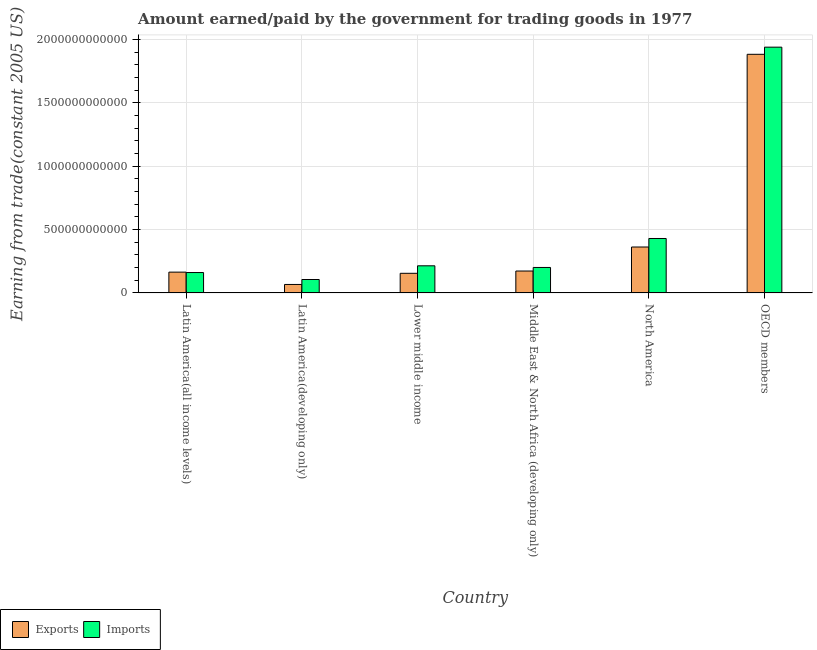How many bars are there on the 5th tick from the right?
Provide a succinct answer. 2. What is the label of the 4th group of bars from the left?
Your answer should be compact. Middle East & North Africa (developing only). In how many cases, is the number of bars for a given country not equal to the number of legend labels?
Provide a succinct answer. 0. What is the amount earned from exports in Middle East & North Africa (developing only)?
Make the answer very short. 1.73e+11. Across all countries, what is the maximum amount earned from exports?
Your answer should be compact. 1.88e+12. Across all countries, what is the minimum amount earned from exports?
Your response must be concise. 6.69e+1. In which country was the amount earned from exports minimum?
Make the answer very short. Latin America(developing only). What is the total amount paid for imports in the graph?
Give a very brief answer. 3.05e+12. What is the difference between the amount paid for imports in Latin America(all income levels) and that in OECD members?
Provide a short and direct response. -1.78e+12. What is the difference between the amount paid for imports in Middle East & North Africa (developing only) and the amount earned from exports in North America?
Give a very brief answer. -1.61e+11. What is the average amount earned from exports per country?
Provide a short and direct response. 4.67e+11. What is the difference between the amount paid for imports and amount earned from exports in Latin America(developing only)?
Your answer should be compact. 3.91e+1. What is the ratio of the amount paid for imports in Latin America(developing only) to that in OECD members?
Your response must be concise. 0.05. Is the amount earned from exports in Latin America(developing only) less than that in North America?
Your answer should be compact. Yes. What is the difference between the highest and the second highest amount earned from exports?
Your answer should be compact. 1.52e+12. What is the difference between the highest and the lowest amount paid for imports?
Offer a very short reply. 1.83e+12. In how many countries, is the amount earned from exports greater than the average amount earned from exports taken over all countries?
Your answer should be very brief. 1. Is the sum of the amount paid for imports in Latin America(developing only) and Middle East & North Africa (developing only) greater than the maximum amount earned from exports across all countries?
Keep it short and to the point. No. What does the 1st bar from the left in Lower middle income represents?
Offer a terse response. Exports. What does the 1st bar from the right in Latin America(all income levels) represents?
Your answer should be very brief. Imports. How many bars are there?
Your answer should be compact. 12. What is the difference between two consecutive major ticks on the Y-axis?
Your response must be concise. 5.00e+11. Are the values on the major ticks of Y-axis written in scientific E-notation?
Offer a terse response. No. Does the graph contain grids?
Keep it short and to the point. Yes. How many legend labels are there?
Make the answer very short. 2. How are the legend labels stacked?
Ensure brevity in your answer.  Horizontal. What is the title of the graph?
Ensure brevity in your answer.  Amount earned/paid by the government for trading goods in 1977. Does "Overweight" appear as one of the legend labels in the graph?
Keep it short and to the point. No. What is the label or title of the X-axis?
Your answer should be very brief. Country. What is the label or title of the Y-axis?
Your response must be concise. Earning from trade(constant 2005 US). What is the Earning from trade(constant 2005 US) of Exports in Latin America(all income levels)?
Offer a terse response. 1.64e+11. What is the Earning from trade(constant 2005 US) of Imports in Latin America(all income levels)?
Keep it short and to the point. 1.61e+11. What is the Earning from trade(constant 2005 US) of Exports in Latin America(developing only)?
Provide a succinct answer. 6.69e+1. What is the Earning from trade(constant 2005 US) in Imports in Latin America(developing only)?
Make the answer very short. 1.06e+11. What is the Earning from trade(constant 2005 US) of Exports in Lower middle income?
Ensure brevity in your answer.  1.55e+11. What is the Earning from trade(constant 2005 US) in Imports in Lower middle income?
Your response must be concise. 2.14e+11. What is the Earning from trade(constant 2005 US) of Exports in Middle East & North Africa (developing only)?
Offer a terse response. 1.73e+11. What is the Earning from trade(constant 2005 US) in Imports in Middle East & North Africa (developing only)?
Ensure brevity in your answer.  2.01e+11. What is the Earning from trade(constant 2005 US) in Exports in North America?
Give a very brief answer. 3.62e+11. What is the Earning from trade(constant 2005 US) in Imports in North America?
Offer a terse response. 4.29e+11. What is the Earning from trade(constant 2005 US) of Exports in OECD members?
Your answer should be compact. 1.88e+12. What is the Earning from trade(constant 2005 US) in Imports in OECD members?
Make the answer very short. 1.94e+12. Across all countries, what is the maximum Earning from trade(constant 2005 US) of Exports?
Your answer should be compact. 1.88e+12. Across all countries, what is the maximum Earning from trade(constant 2005 US) of Imports?
Give a very brief answer. 1.94e+12. Across all countries, what is the minimum Earning from trade(constant 2005 US) of Exports?
Provide a short and direct response. 6.69e+1. Across all countries, what is the minimum Earning from trade(constant 2005 US) of Imports?
Offer a very short reply. 1.06e+11. What is the total Earning from trade(constant 2005 US) in Exports in the graph?
Keep it short and to the point. 2.80e+12. What is the total Earning from trade(constant 2005 US) in Imports in the graph?
Give a very brief answer. 3.05e+12. What is the difference between the Earning from trade(constant 2005 US) in Exports in Latin America(all income levels) and that in Latin America(developing only)?
Provide a succinct answer. 9.72e+1. What is the difference between the Earning from trade(constant 2005 US) in Imports in Latin America(all income levels) and that in Latin America(developing only)?
Ensure brevity in your answer.  5.50e+1. What is the difference between the Earning from trade(constant 2005 US) of Exports in Latin America(all income levels) and that in Lower middle income?
Your answer should be compact. 9.28e+09. What is the difference between the Earning from trade(constant 2005 US) in Imports in Latin America(all income levels) and that in Lower middle income?
Provide a succinct answer. -5.31e+1. What is the difference between the Earning from trade(constant 2005 US) in Exports in Latin America(all income levels) and that in Middle East & North Africa (developing only)?
Provide a short and direct response. -8.78e+09. What is the difference between the Earning from trade(constant 2005 US) of Imports in Latin America(all income levels) and that in Middle East & North Africa (developing only)?
Your answer should be compact. -4.00e+1. What is the difference between the Earning from trade(constant 2005 US) of Exports in Latin America(all income levels) and that in North America?
Give a very brief answer. -1.98e+11. What is the difference between the Earning from trade(constant 2005 US) of Imports in Latin America(all income levels) and that in North America?
Offer a very short reply. -2.69e+11. What is the difference between the Earning from trade(constant 2005 US) in Exports in Latin America(all income levels) and that in OECD members?
Offer a very short reply. -1.72e+12. What is the difference between the Earning from trade(constant 2005 US) in Imports in Latin America(all income levels) and that in OECD members?
Offer a very short reply. -1.78e+12. What is the difference between the Earning from trade(constant 2005 US) of Exports in Latin America(developing only) and that in Lower middle income?
Provide a succinct answer. -8.79e+1. What is the difference between the Earning from trade(constant 2005 US) of Imports in Latin America(developing only) and that in Lower middle income?
Offer a very short reply. -1.08e+11. What is the difference between the Earning from trade(constant 2005 US) in Exports in Latin America(developing only) and that in Middle East & North Africa (developing only)?
Your answer should be very brief. -1.06e+11. What is the difference between the Earning from trade(constant 2005 US) in Imports in Latin America(developing only) and that in Middle East & North Africa (developing only)?
Provide a succinct answer. -9.50e+1. What is the difference between the Earning from trade(constant 2005 US) of Exports in Latin America(developing only) and that in North America?
Your answer should be compact. -2.95e+11. What is the difference between the Earning from trade(constant 2005 US) of Imports in Latin America(developing only) and that in North America?
Offer a very short reply. -3.24e+11. What is the difference between the Earning from trade(constant 2005 US) of Exports in Latin America(developing only) and that in OECD members?
Offer a very short reply. -1.82e+12. What is the difference between the Earning from trade(constant 2005 US) in Imports in Latin America(developing only) and that in OECD members?
Your answer should be very brief. -1.83e+12. What is the difference between the Earning from trade(constant 2005 US) of Exports in Lower middle income and that in Middle East & North Africa (developing only)?
Provide a succinct answer. -1.81e+1. What is the difference between the Earning from trade(constant 2005 US) of Imports in Lower middle income and that in Middle East & North Africa (developing only)?
Make the answer very short. 1.31e+1. What is the difference between the Earning from trade(constant 2005 US) in Exports in Lower middle income and that in North America?
Provide a succinct answer. -2.07e+11. What is the difference between the Earning from trade(constant 2005 US) of Imports in Lower middle income and that in North America?
Your answer should be compact. -2.15e+11. What is the difference between the Earning from trade(constant 2005 US) in Exports in Lower middle income and that in OECD members?
Offer a terse response. -1.73e+12. What is the difference between the Earning from trade(constant 2005 US) of Imports in Lower middle income and that in OECD members?
Provide a short and direct response. -1.72e+12. What is the difference between the Earning from trade(constant 2005 US) in Exports in Middle East & North Africa (developing only) and that in North America?
Provide a succinct answer. -1.89e+11. What is the difference between the Earning from trade(constant 2005 US) in Imports in Middle East & North Africa (developing only) and that in North America?
Your answer should be very brief. -2.29e+11. What is the difference between the Earning from trade(constant 2005 US) in Exports in Middle East & North Africa (developing only) and that in OECD members?
Your answer should be compact. -1.71e+12. What is the difference between the Earning from trade(constant 2005 US) in Imports in Middle East & North Africa (developing only) and that in OECD members?
Keep it short and to the point. -1.74e+12. What is the difference between the Earning from trade(constant 2005 US) in Exports in North America and that in OECD members?
Keep it short and to the point. -1.52e+12. What is the difference between the Earning from trade(constant 2005 US) of Imports in North America and that in OECD members?
Make the answer very short. -1.51e+12. What is the difference between the Earning from trade(constant 2005 US) in Exports in Latin America(all income levels) and the Earning from trade(constant 2005 US) in Imports in Latin America(developing only)?
Your answer should be compact. 5.81e+1. What is the difference between the Earning from trade(constant 2005 US) in Exports in Latin America(all income levels) and the Earning from trade(constant 2005 US) in Imports in Lower middle income?
Your answer should be compact. -4.99e+1. What is the difference between the Earning from trade(constant 2005 US) of Exports in Latin America(all income levels) and the Earning from trade(constant 2005 US) of Imports in Middle East & North Africa (developing only)?
Ensure brevity in your answer.  -3.68e+1. What is the difference between the Earning from trade(constant 2005 US) in Exports in Latin America(all income levels) and the Earning from trade(constant 2005 US) in Imports in North America?
Ensure brevity in your answer.  -2.65e+11. What is the difference between the Earning from trade(constant 2005 US) of Exports in Latin America(all income levels) and the Earning from trade(constant 2005 US) of Imports in OECD members?
Provide a short and direct response. -1.77e+12. What is the difference between the Earning from trade(constant 2005 US) in Exports in Latin America(developing only) and the Earning from trade(constant 2005 US) in Imports in Lower middle income?
Your answer should be compact. -1.47e+11. What is the difference between the Earning from trade(constant 2005 US) of Exports in Latin America(developing only) and the Earning from trade(constant 2005 US) of Imports in Middle East & North Africa (developing only)?
Offer a terse response. -1.34e+11. What is the difference between the Earning from trade(constant 2005 US) of Exports in Latin America(developing only) and the Earning from trade(constant 2005 US) of Imports in North America?
Offer a terse response. -3.63e+11. What is the difference between the Earning from trade(constant 2005 US) in Exports in Latin America(developing only) and the Earning from trade(constant 2005 US) in Imports in OECD members?
Your answer should be compact. -1.87e+12. What is the difference between the Earning from trade(constant 2005 US) of Exports in Lower middle income and the Earning from trade(constant 2005 US) of Imports in Middle East & North Africa (developing only)?
Your answer should be compact. -4.61e+1. What is the difference between the Earning from trade(constant 2005 US) of Exports in Lower middle income and the Earning from trade(constant 2005 US) of Imports in North America?
Provide a short and direct response. -2.75e+11. What is the difference between the Earning from trade(constant 2005 US) in Exports in Lower middle income and the Earning from trade(constant 2005 US) in Imports in OECD members?
Provide a short and direct response. -1.78e+12. What is the difference between the Earning from trade(constant 2005 US) in Exports in Middle East & North Africa (developing only) and the Earning from trade(constant 2005 US) in Imports in North America?
Offer a terse response. -2.57e+11. What is the difference between the Earning from trade(constant 2005 US) in Exports in Middle East & North Africa (developing only) and the Earning from trade(constant 2005 US) in Imports in OECD members?
Your answer should be very brief. -1.77e+12. What is the difference between the Earning from trade(constant 2005 US) of Exports in North America and the Earning from trade(constant 2005 US) of Imports in OECD members?
Ensure brevity in your answer.  -1.58e+12. What is the average Earning from trade(constant 2005 US) of Exports per country?
Give a very brief answer. 4.67e+11. What is the average Earning from trade(constant 2005 US) in Imports per country?
Provide a succinct answer. 5.08e+11. What is the difference between the Earning from trade(constant 2005 US) of Exports and Earning from trade(constant 2005 US) of Imports in Latin America(all income levels)?
Your response must be concise. 3.17e+09. What is the difference between the Earning from trade(constant 2005 US) of Exports and Earning from trade(constant 2005 US) of Imports in Latin America(developing only)?
Your answer should be very brief. -3.91e+1. What is the difference between the Earning from trade(constant 2005 US) in Exports and Earning from trade(constant 2005 US) in Imports in Lower middle income?
Make the answer very short. -5.92e+1. What is the difference between the Earning from trade(constant 2005 US) of Exports and Earning from trade(constant 2005 US) of Imports in Middle East & North Africa (developing only)?
Your answer should be very brief. -2.81e+1. What is the difference between the Earning from trade(constant 2005 US) in Exports and Earning from trade(constant 2005 US) in Imports in North America?
Make the answer very short. -6.72e+1. What is the difference between the Earning from trade(constant 2005 US) of Exports and Earning from trade(constant 2005 US) of Imports in OECD members?
Your answer should be very brief. -5.63e+1. What is the ratio of the Earning from trade(constant 2005 US) of Exports in Latin America(all income levels) to that in Latin America(developing only)?
Offer a very short reply. 2.45. What is the ratio of the Earning from trade(constant 2005 US) of Imports in Latin America(all income levels) to that in Latin America(developing only)?
Your response must be concise. 1.52. What is the ratio of the Earning from trade(constant 2005 US) of Exports in Latin America(all income levels) to that in Lower middle income?
Your response must be concise. 1.06. What is the ratio of the Earning from trade(constant 2005 US) of Imports in Latin America(all income levels) to that in Lower middle income?
Your answer should be very brief. 0.75. What is the ratio of the Earning from trade(constant 2005 US) in Exports in Latin America(all income levels) to that in Middle East & North Africa (developing only)?
Offer a terse response. 0.95. What is the ratio of the Earning from trade(constant 2005 US) in Imports in Latin America(all income levels) to that in Middle East & North Africa (developing only)?
Provide a succinct answer. 0.8. What is the ratio of the Earning from trade(constant 2005 US) of Exports in Latin America(all income levels) to that in North America?
Keep it short and to the point. 0.45. What is the ratio of the Earning from trade(constant 2005 US) in Imports in Latin America(all income levels) to that in North America?
Your answer should be compact. 0.37. What is the ratio of the Earning from trade(constant 2005 US) in Exports in Latin America(all income levels) to that in OECD members?
Keep it short and to the point. 0.09. What is the ratio of the Earning from trade(constant 2005 US) in Imports in Latin America(all income levels) to that in OECD members?
Ensure brevity in your answer.  0.08. What is the ratio of the Earning from trade(constant 2005 US) in Exports in Latin America(developing only) to that in Lower middle income?
Offer a terse response. 0.43. What is the ratio of the Earning from trade(constant 2005 US) of Imports in Latin America(developing only) to that in Lower middle income?
Keep it short and to the point. 0.5. What is the ratio of the Earning from trade(constant 2005 US) in Exports in Latin America(developing only) to that in Middle East & North Africa (developing only)?
Ensure brevity in your answer.  0.39. What is the ratio of the Earning from trade(constant 2005 US) of Imports in Latin America(developing only) to that in Middle East & North Africa (developing only)?
Offer a terse response. 0.53. What is the ratio of the Earning from trade(constant 2005 US) of Exports in Latin America(developing only) to that in North America?
Your answer should be very brief. 0.18. What is the ratio of the Earning from trade(constant 2005 US) of Imports in Latin America(developing only) to that in North America?
Offer a terse response. 0.25. What is the ratio of the Earning from trade(constant 2005 US) of Exports in Latin America(developing only) to that in OECD members?
Your answer should be very brief. 0.04. What is the ratio of the Earning from trade(constant 2005 US) in Imports in Latin America(developing only) to that in OECD members?
Make the answer very short. 0.05. What is the ratio of the Earning from trade(constant 2005 US) of Exports in Lower middle income to that in Middle East & North Africa (developing only)?
Ensure brevity in your answer.  0.9. What is the ratio of the Earning from trade(constant 2005 US) in Imports in Lower middle income to that in Middle East & North Africa (developing only)?
Provide a succinct answer. 1.07. What is the ratio of the Earning from trade(constant 2005 US) of Exports in Lower middle income to that in North America?
Keep it short and to the point. 0.43. What is the ratio of the Earning from trade(constant 2005 US) of Imports in Lower middle income to that in North America?
Your answer should be compact. 0.5. What is the ratio of the Earning from trade(constant 2005 US) in Exports in Lower middle income to that in OECD members?
Keep it short and to the point. 0.08. What is the ratio of the Earning from trade(constant 2005 US) in Imports in Lower middle income to that in OECD members?
Offer a terse response. 0.11. What is the ratio of the Earning from trade(constant 2005 US) in Exports in Middle East & North Africa (developing only) to that in North America?
Ensure brevity in your answer.  0.48. What is the ratio of the Earning from trade(constant 2005 US) in Imports in Middle East & North Africa (developing only) to that in North America?
Make the answer very short. 0.47. What is the ratio of the Earning from trade(constant 2005 US) in Exports in Middle East & North Africa (developing only) to that in OECD members?
Provide a short and direct response. 0.09. What is the ratio of the Earning from trade(constant 2005 US) in Imports in Middle East & North Africa (developing only) to that in OECD members?
Provide a succinct answer. 0.1. What is the ratio of the Earning from trade(constant 2005 US) of Exports in North America to that in OECD members?
Your response must be concise. 0.19. What is the ratio of the Earning from trade(constant 2005 US) of Imports in North America to that in OECD members?
Your answer should be compact. 0.22. What is the difference between the highest and the second highest Earning from trade(constant 2005 US) in Exports?
Make the answer very short. 1.52e+12. What is the difference between the highest and the second highest Earning from trade(constant 2005 US) of Imports?
Offer a very short reply. 1.51e+12. What is the difference between the highest and the lowest Earning from trade(constant 2005 US) in Exports?
Give a very brief answer. 1.82e+12. What is the difference between the highest and the lowest Earning from trade(constant 2005 US) in Imports?
Give a very brief answer. 1.83e+12. 